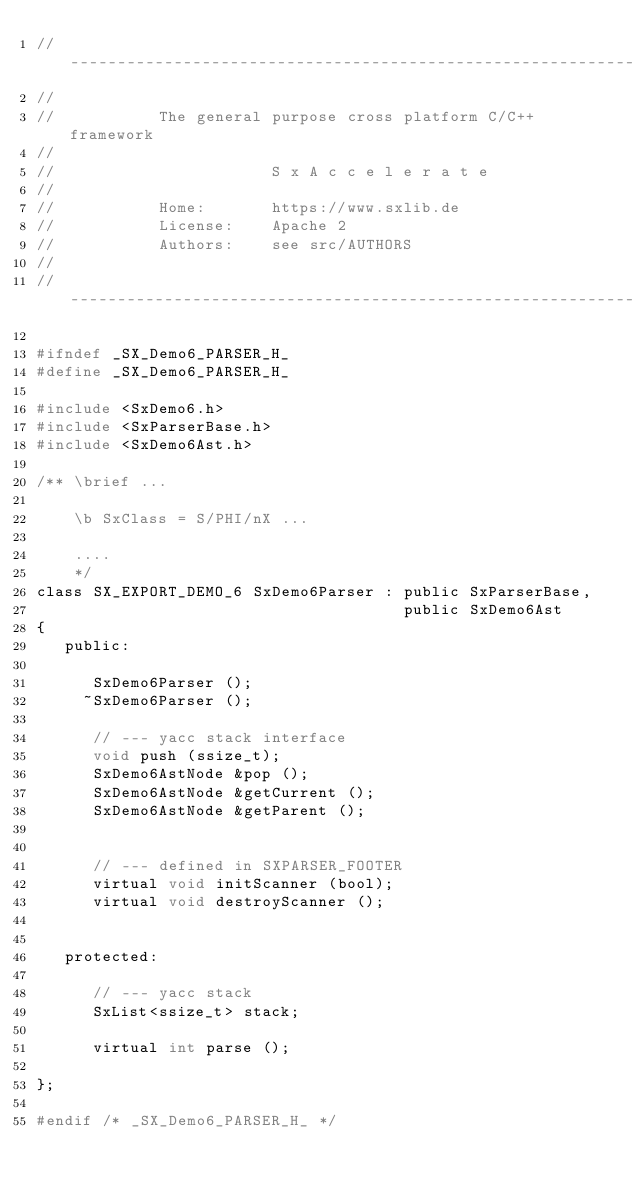<code> <loc_0><loc_0><loc_500><loc_500><_C_>// ---------------------------------------------------------------------------
//
//           The general purpose cross platform C/C++ framework
//
//                       S x A c c e l e r a t e
//
//           Home:       https://www.sxlib.de
//           License:    Apache 2
//           Authors:    see src/AUTHORS
//
// ---------------------------------------------------------------------------

#ifndef _SX_Demo6_PARSER_H_
#define _SX_Demo6_PARSER_H_

#include <SxDemo6.h>
#include <SxParserBase.h>
#include <SxDemo6Ast.h>

/** \brief ...

    \b SxClass = S/PHI/nX ...

    ....
    */
class SX_EXPORT_DEMO_6 SxDemo6Parser : public SxParserBase,
                                       public SxDemo6Ast
{
   public:

      SxDemo6Parser ();
     ~SxDemo6Parser ();

      // --- yacc stack interface
      void push (ssize_t);
      SxDemo6AstNode &pop ();
      SxDemo6AstNode &getCurrent ();
      SxDemo6AstNode &getParent ();


      // --- defined in SXPARSER_FOOTER
      virtual void initScanner (bool);
      virtual void destroyScanner ();


   protected:

      // --- yacc stack
      SxList<ssize_t> stack;

      virtual int parse ();

};

#endif /* _SX_Demo6_PARSER_H_ */
</code> 